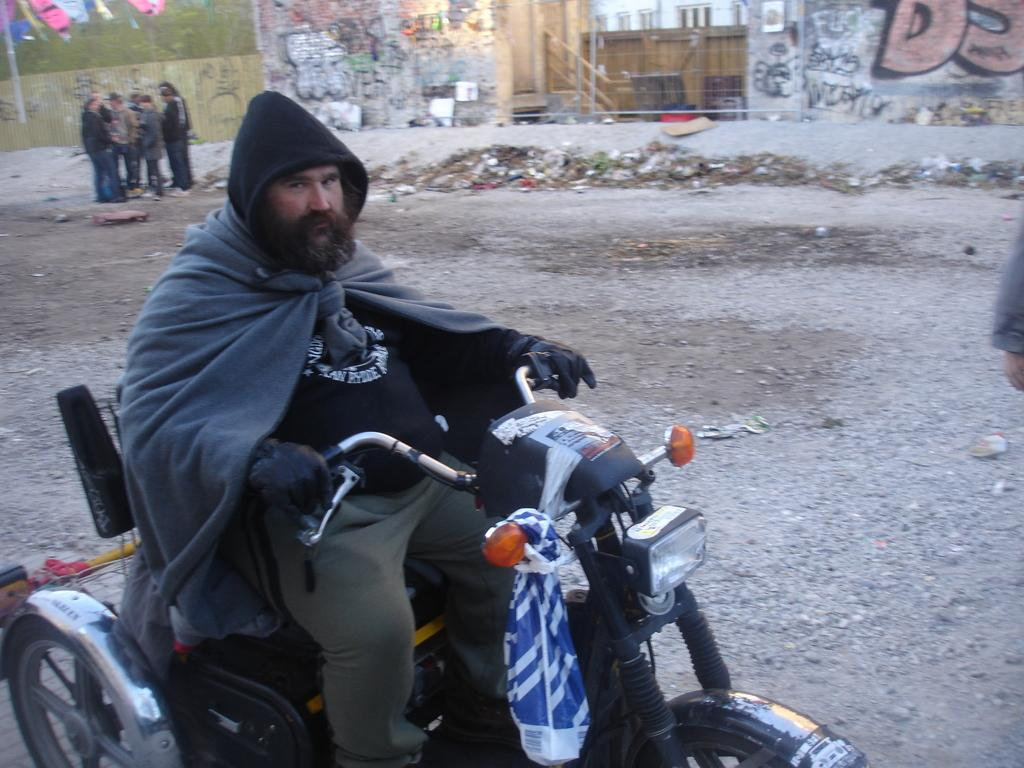What is the main subject of the image? The main subject of the image is a man. What is the man doing in the image? The man is riding a vehicle. Are there any other people in the image? Yes, there is a group of people beside the man. What type of parcel is the man holding while riding the vehicle? There is no parcel visible in the image; the man is simply riding the vehicle. 